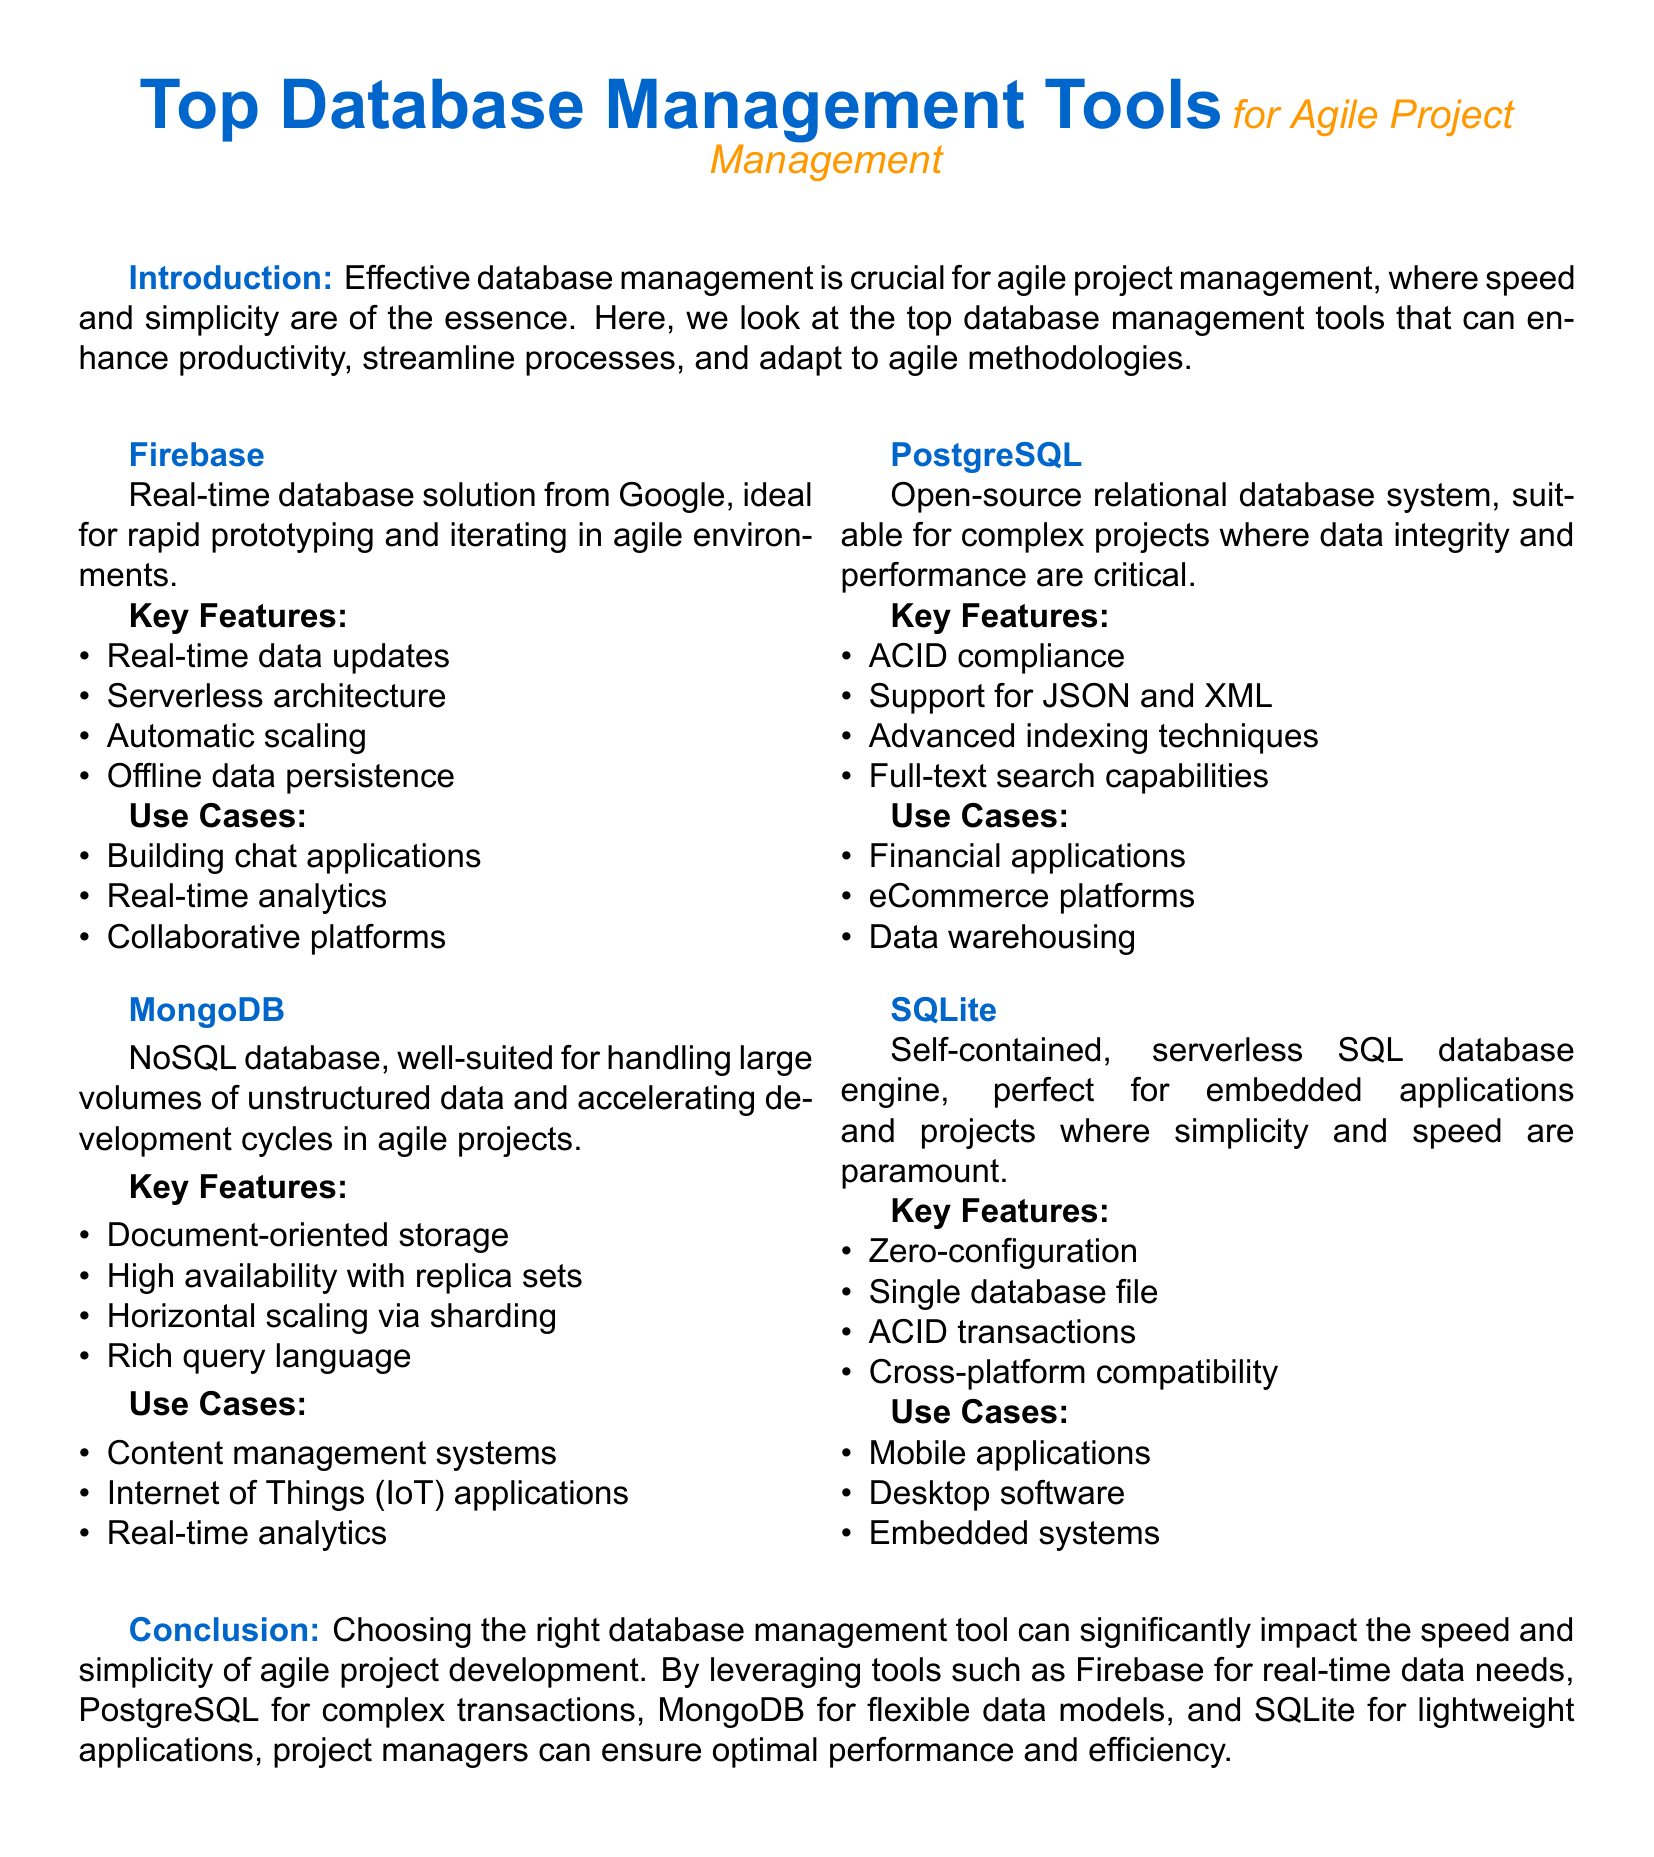What is the main color used in the document? The main color is defined as RGB(0,102,204), which is used throughout the document for headings and titles.
Answer: maincolor Which database management tool is ideal for rapid prototyping? The document states that Firebase is a real-time database solution from Google, ideal for rapid prototyping and iterating in agile environments.
Answer: Firebase What is a key feature of PostgreSQL? PostgreSQL is highlighted for its ACID compliance, which ensures data integrity in transactions.
Answer: ACID compliance What type of database is MongoDB? The document classifies MongoDB as a NoSQL database, suitable for handling large volumes of unstructured data.
Answer: NoSQL For what application is SQLite particularly suited? SQLite is mentioned to be perfect for embedded applications and projects where simplicity and speed are paramount.
Answer: embedded applications How does MongoDB ensure high availability? The document states that MongoDB ensures high availability through replica sets, which maintain copies of data.
Answer: replica sets What are the use cases for Firebase? The document lists building chat applications, real-time analytics, and collaborative platforms among the use cases for Firebase.
Answer: Chat applications, real-time analytics, collaborative platforms Which database is recommended for complex projects? The document suggests using PostgreSQL for complex projects where data integrity and performance are critical.
Answer: PostgreSQL What is the key benefit of SQLite's simplicity? The document emphasizes that SQLite is a self-contained, serverless SQL database engine, highlighting its zero-configuration requirement.
Answer: zero-configuration 